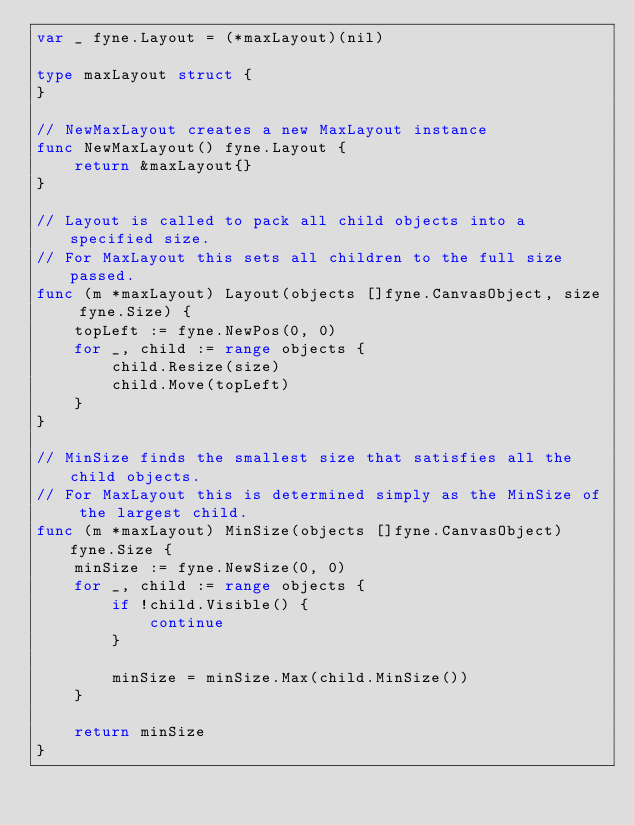Convert code to text. <code><loc_0><loc_0><loc_500><loc_500><_Go_>var _ fyne.Layout = (*maxLayout)(nil)

type maxLayout struct {
}

// NewMaxLayout creates a new MaxLayout instance
func NewMaxLayout() fyne.Layout {
	return &maxLayout{}
}

// Layout is called to pack all child objects into a specified size.
// For MaxLayout this sets all children to the full size passed.
func (m *maxLayout) Layout(objects []fyne.CanvasObject, size fyne.Size) {
	topLeft := fyne.NewPos(0, 0)
	for _, child := range objects {
		child.Resize(size)
		child.Move(topLeft)
	}
}

// MinSize finds the smallest size that satisfies all the child objects.
// For MaxLayout this is determined simply as the MinSize of the largest child.
func (m *maxLayout) MinSize(objects []fyne.CanvasObject) fyne.Size {
	minSize := fyne.NewSize(0, 0)
	for _, child := range objects {
		if !child.Visible() {
			continue
		}

		minSize = minSize.Max(child.MinSize())
	}

	return minSize
}
</code> 